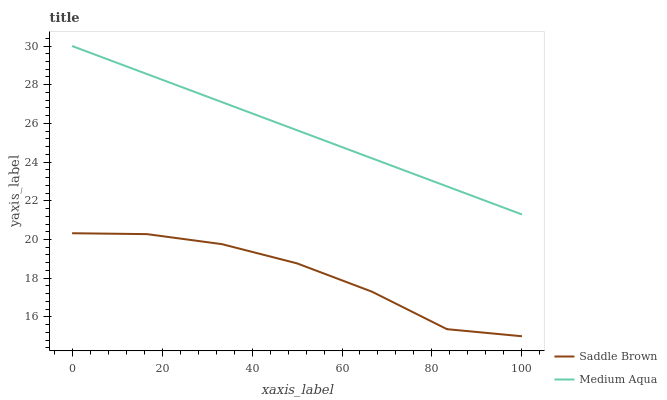Does Saddle Brown have the minimum area under the curve?
Answer yes or no. Yes. Does Medium Aqua have the maximum area under the curve?
Answer yes or no. Yes. Does Saddle Brown have the maximum area under the curve?
Answer yes or no. No. Is Medium Aqua the smoothest?
Answer yes or no. Yes. Is Saddle Brown the roughest?
Answer yes or no. Yes. Is Saddle Brown the smoothest?
Answer yes or no. No. Does Saddle Brown have the lowest value?
Answer yes or no. Yes. Does Medium Aqua have the highest value?
Answer yes or no. Yes. Does Saddle Brown have the highest value?
Answer yes or no. No. Is Saddle Brown less than Medium Aqua?
Answer yes or no. Yes. Is Medium Aqua greater than Saddle Brown?
Answer yes or no. Yes. Does Saddle Brown intersect Medium Aqua?
Answer yes or no. No. 